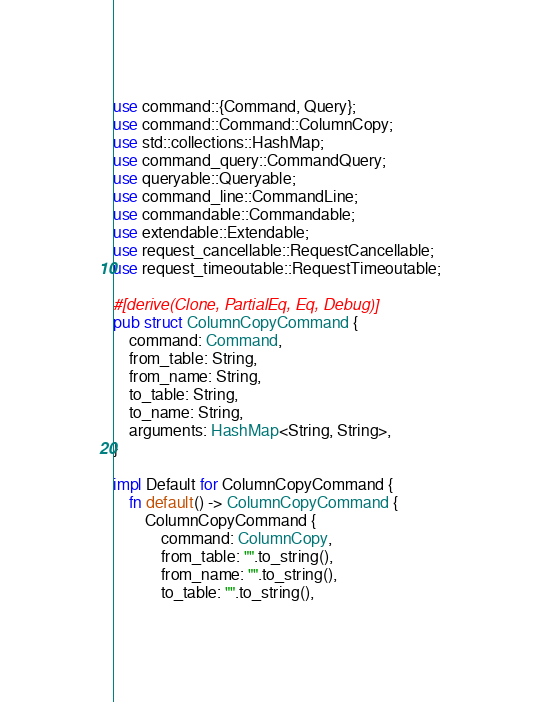Convert code to text. <code><loc_0><loc_0><loc_500><loc_500><_Rust_>use command::{Command, Query};
use command::Command::ColumnCopy;
use std::collections::HashMap;
use command_query::CommandQuery;
use queryable::Queryable;
use command_line::CommandLine;
use commandable::Commandable;
use extendable::Extendable;
use request_cancellable::RequestCancellable;
use request_timeoutable::RequestTimeoutable;

#[derive(Clone, PartialEq, Eq, Debug)]
pub struct ColumnCopyCommand {
    command: Command,
    from_table: String,
    from_name: String,
    to_table: String,
    to_name: String,
    arguments: HashMap<String, String>,
}

impl Default for ColumnCopyCommand {
    fn default() -> ColumnCopyCommand {
        ColumnCopyCommand {
            command: ColumnCopy,
            from_table: "".to_string(),
            from_name: "".to_string(),
            to_table: "".to_string(),</code> 